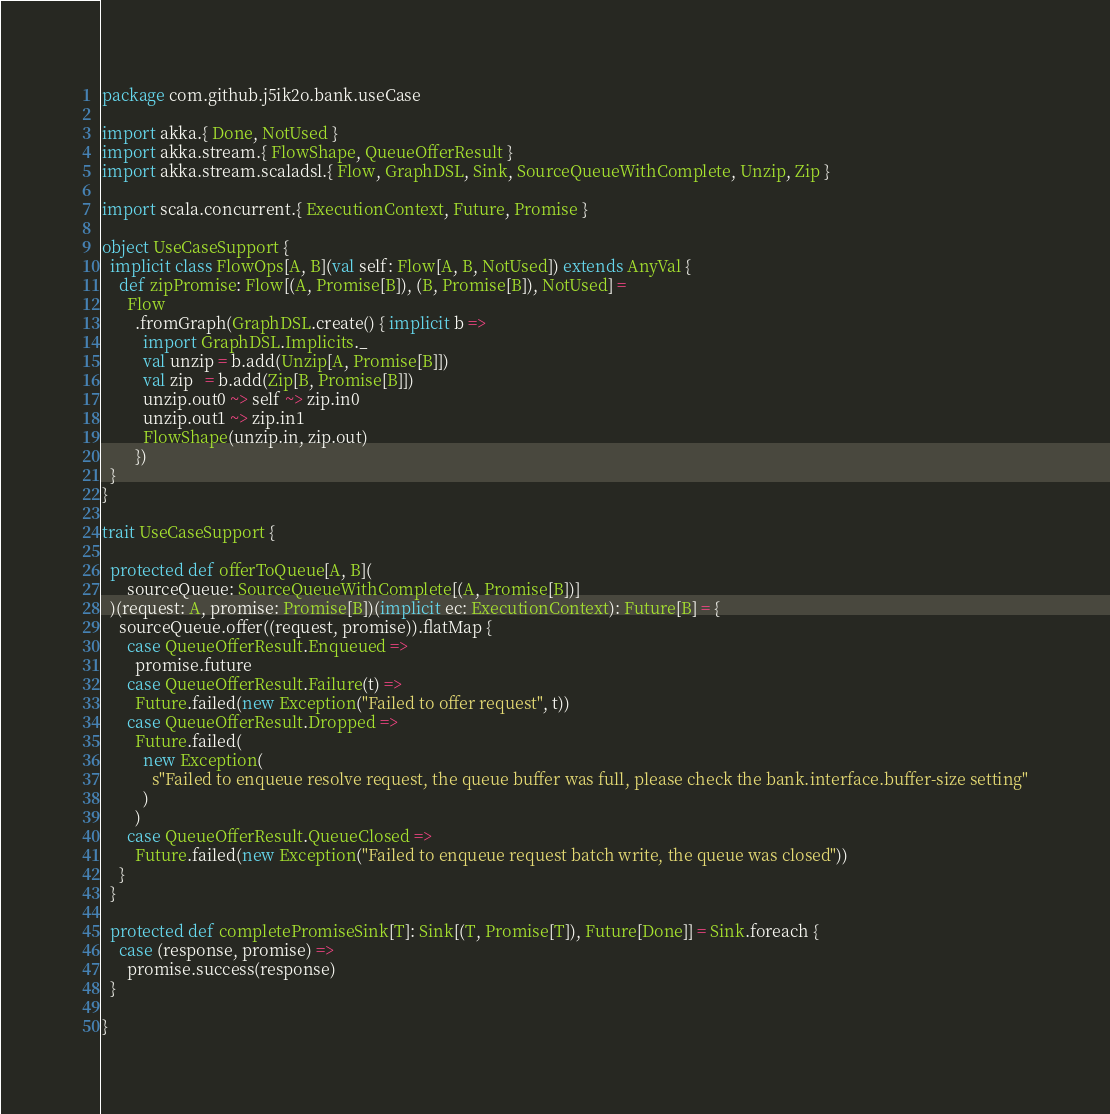Convert code to text. <code><loc_0><loc_0><loc_500><loc_500><_Scala_>package com.github.j5ik2o.bank.useCase

import akka.{ Done, NotUsed }
import akka.stream.{ FlowShape, QueueOfferResult }
import akka.stream.scaladsl.{ Flow, GraphDSL, Sink, SourceQueueWithComplete, Unzip, Zip }

import scala.concurrent.{ ExecutionContext, Future, Promise }

object UseCaseSupport {
  implicit class FlowOps[A, B](val self: Flow[A, B, NotUsed]) extends AnyVal {
    def zipPromise: Flow[(A, Promise[B]), (B, Promise[B]), NotUsed] =
      Flow
        .fromGraph(GraphDSL.create() { implicit b =>
          import GraphDSL.Implicits._
          val unzip = b.add(Unzip[A, Promise[B]])
          val zip   = b.add(Zip[B, Promise[B]])
          unzip.out0 ~> self ~> zip.in0
          unzip.out1 ~> zip.in1
          FlowShape(unzip.in, zip.out)
        })
  }
}

trait UseCaseSupport {

  protected def offerToQueue[A, B](
      sourceQueue: SourceQueueWithComplete[(A, Promise[B])]
  )(request: A, promise: Promise[B])(implicit ec: ExecutionContext): Future[B] = {
    sourceQueue.offer((request, promise)).flatMap {
      case QueueOfferResult.Enqueued =>
        promise.future
      case QueueOfferResult.Failure(t) =>
        Future.failed(new Exception("Failed to offer request", t))
      case QueueOfferResult.Dropped =>
        Future.failed(
          new Exception(
            s"Failed to enqueue resolve request, the queue buffer was full, please check the bank.interface.buffer-size setting"
          )
        )
      case QueueOfferResult.QueueClosed =>
        Future.failed(new Exception("Failed to enqueue request batch write, the queue was closed"))
    }
  }

  protected def completePromiseSink[T]: Sink[(T, Promise[T]), Future[Done]] = Sink.foreach {
    case (response, promise) =>
      promise.success(response)
  }

}
</code> 